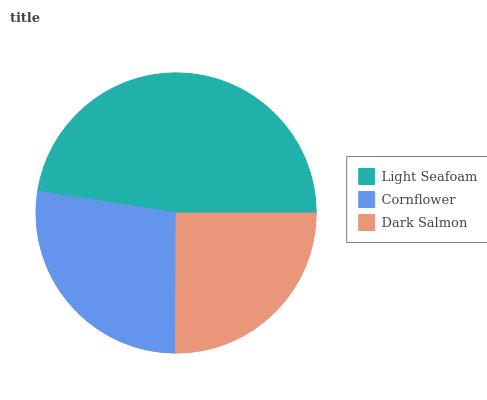Is Dark Salmon the minimum?
Answer yes or no. Yes. Is Light Seafoam the maximum?
Answer yes or no. Yes. Is Cornflower the minimum?
Answer yes or no. No. Is Cornflower the maximum?
Answer yes or no. No. Is Light Seafoam greater than Cornflower?
Answer yes or no. Yes. Is Cornflower less than Light Seafoam?
Answer yes or no. Yes. Is Cornflower greater than Light Seafoam?
Answer yes or no. No. Is Light Seafoam less than Cornflower?
Answer yes or no. No. Is Cornflower the high median?
Answer yes or no. Yes. Is Cornflower the low median?
Answer yes or no. Yes. Is Light Seafoam the high median?
Answer yes or no. No. Is Light Seafoam the low median?
Answer yes or no. No. 